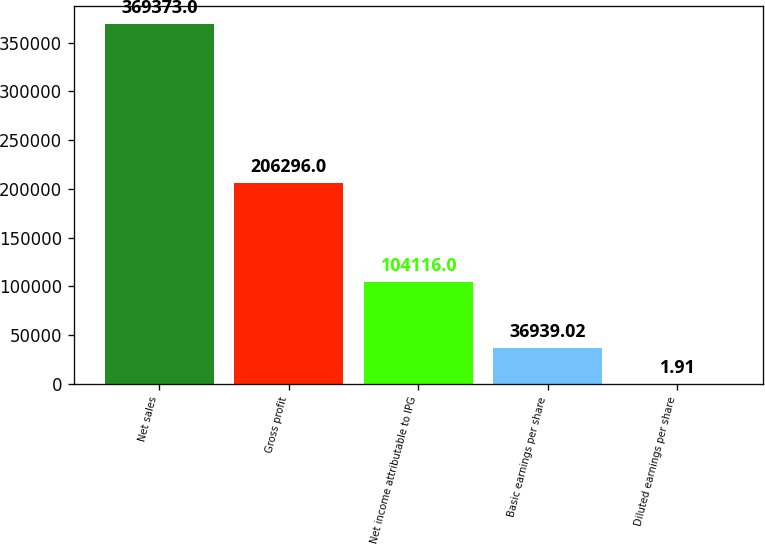<chart> <loc_0><loc_0><loc_500><loc_500><bar_chart><fcel>Net sales<fcel>Gross profit<fcel>Net income attributable to IPG<fcel>Basic earnings per share<fcel>Diluted earnings per share<nl><fcel>369373<fcel>206296<fcel>104116<fcel>36939<fcel>1.91<nl></chart> 